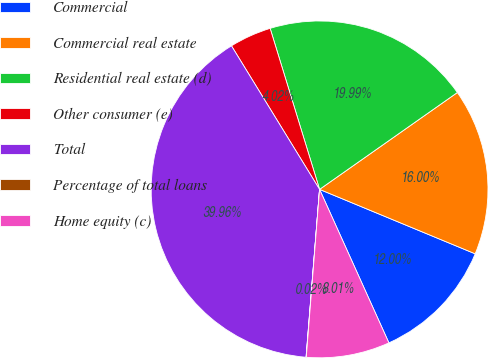<chart> <loc_0><loc_0><loc_500><loc_500><pie_chart><fcel>Commercial<fcel>Commercial real estate<fcel>Residential real estate (d)<fcel>Other consumer (e)<fcel>Total<fcel>Percentage of total loans<fcel>Home equity (c)<nl><fcel>12.0%<fcel>16.0%<fcel>19.99%<fcel>4.02%<fcel>39.96%<fcel>0.02%<fcel>8.01%<nl></chart> 